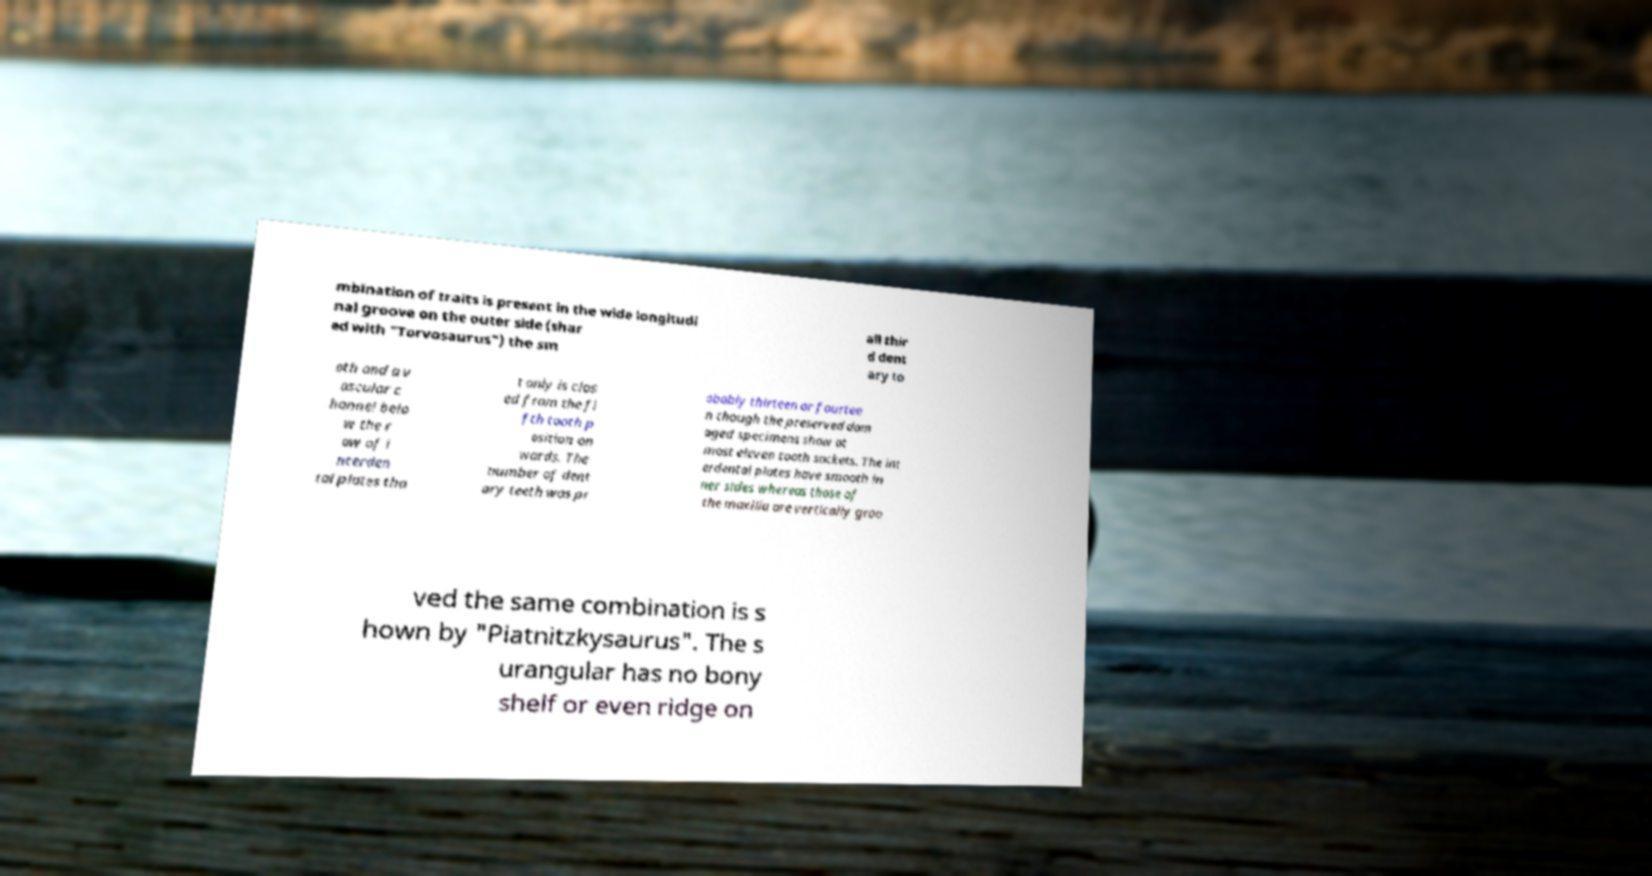Please read and relay the text visible in this image. What does it say? mbination of traits is present in the wide longitudi nal groove on the outer side (shar ed with "Torvosaurus") the sm all thir d dent ary to oth and a v ascular c hannel belo w the r ow of i nterden tal plates tha t only is clos ed from the fi fth tooth p osition on wards. The number of dent ary teeth was pr obably thirteen or fourtee n though the preserved dam aged specimens show at most eleven tooth sockets. The int erdental plates have smooth in ner sides whereas those of the maxilla are vertically groo ved the same combination is s hown by "Piatnitzkysaurus". The s urangular has no bony shelf or even ridge on 